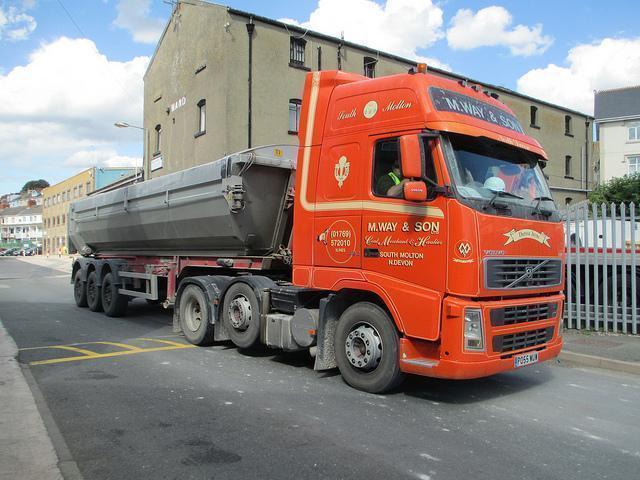What business park does this company operate out of?
Choose the correct response and explain in the format: 'Answer: answer
Rationale: rationale.'
Options: Pathfields, safeways, journeyman, legacy. Answer: pathfields.
Rationale: Looks like a pathfields truck. 